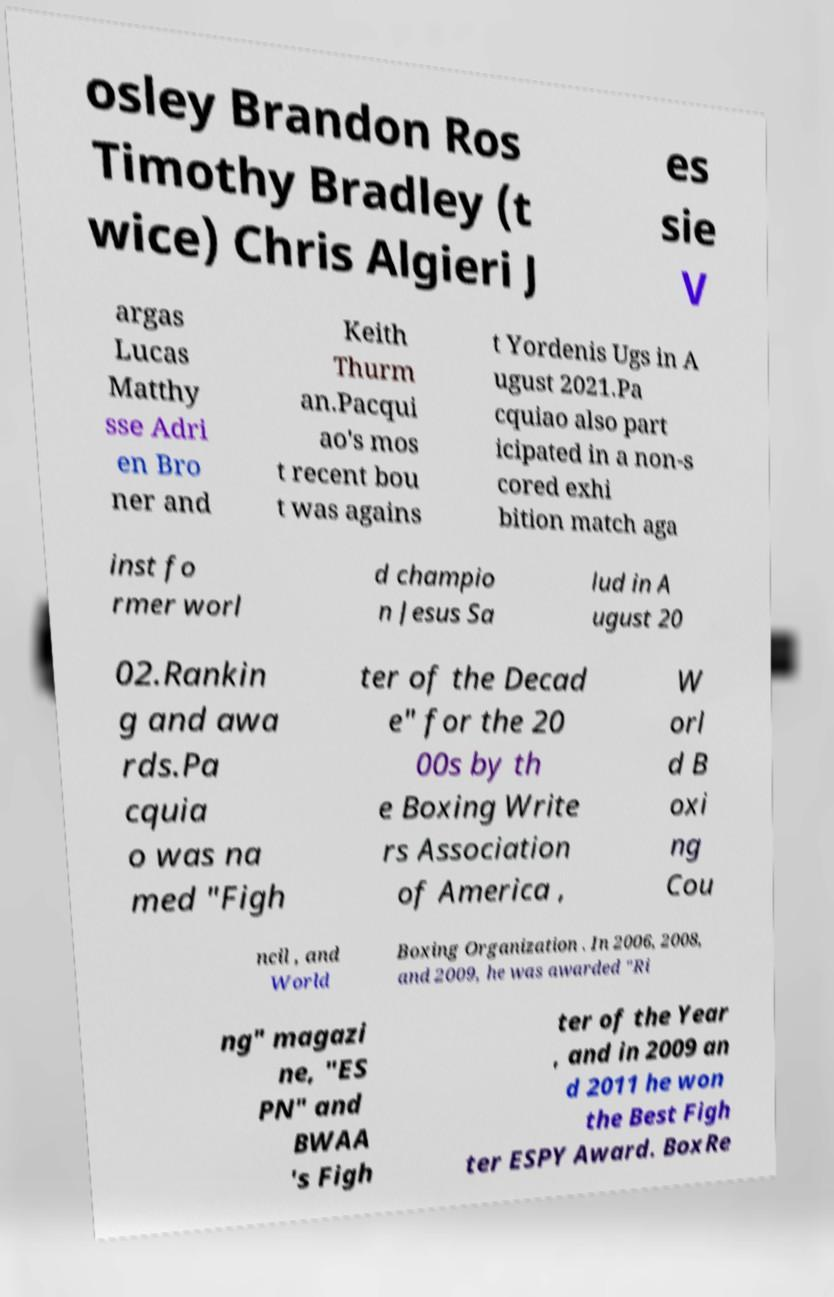Please identify and transcribe the text found in this image. osley Brandon Ros Timothy Bradley (t wice) Chris Algieri J es sie V argas Lucas Matthy sse Adri en Bro ner and Keith Thurm an.Pacqui ao's mos t recent bou t was agains t Yordenis Ugs in A ugust 2021.Pa cquiao also part icipated in a non-s cored exhi bition match aga inst fo rmer worl d champio n Jesus Sa lud in A ugust 20 02.Rankin g and awa rds.Pa cquia o was na med "Figh ter of the Decad e" for the 20 00s by th e Boxing Write rs Association of America , W orl d B oxi ng Cou ncil , and World Boxing Organization . In 2006, 2008, and 2009, he was awarded "Ri ng" magazi ne, "ES PN" and BWAA 's Figh ter of the Year , and in 2009 an d 2011 he won the Best Figh ter ESPY Award. BoxRe 